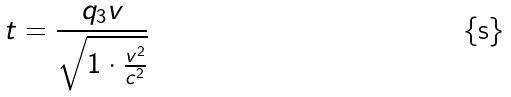<formula> <loc_0><loc_0><loc_500><loc_500>t = \frac { q _ { 3 } v } { \sqrt { 1 \cdot \frac { v ^ { 2 } } { c ^ { 2 } } } }</formula> 